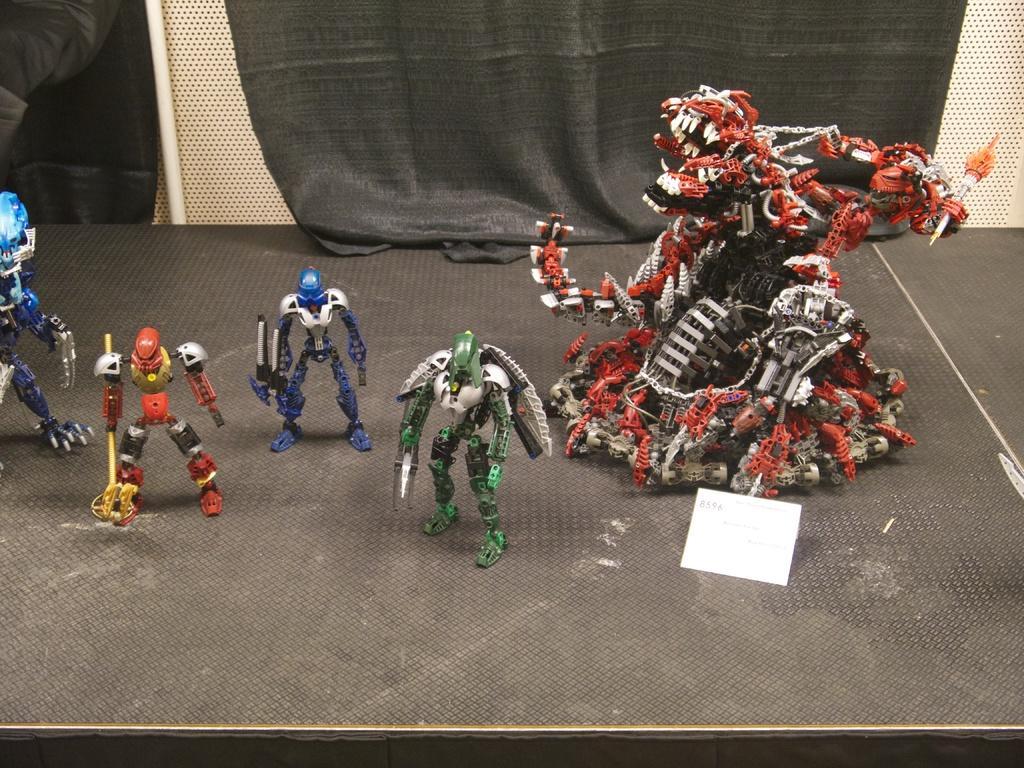In one or two sentences, can you explain what this image depicts? In this image we can see toy robots on a platform. There is a paper. In the background we can see a cloth. 